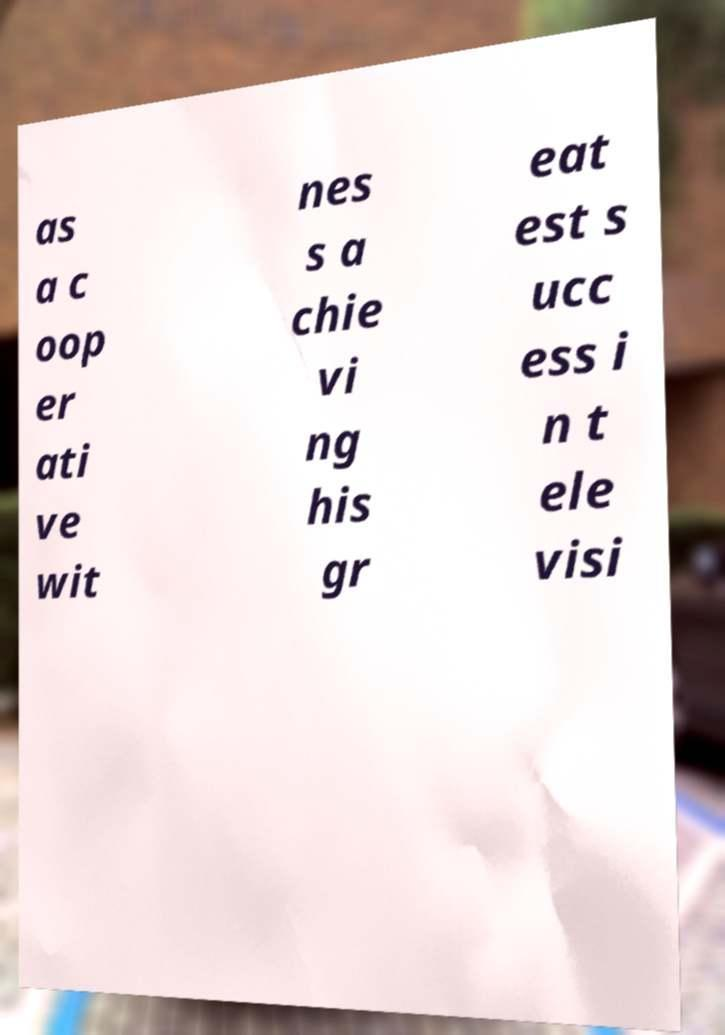For documentation purposes, I need the text within this image transcribed. Could you provide that? as a c oop er ati ve wit nes s a chie vi ng his gr eat est s ucc ess i n t ele visi 